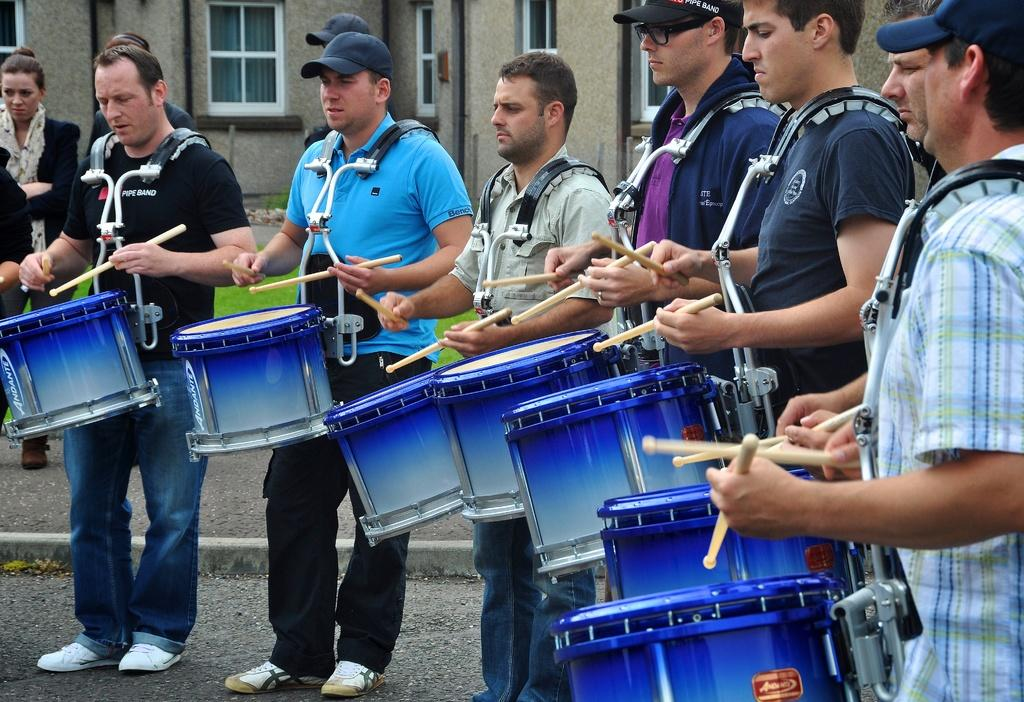What are the people in the image doing? The people in the image are playing drums. Where are the people located in the image? The people are standing in the center of the image. What can be seen in the background of the image? There is a building in the background of the image. What is at the bottom of the image? There is a road at the bottom of the image. Reasoning: Let' Let's think step by step in order to produce the conversation. We start by identifying the main action taking place in the image, which is the people playing drums. Then, we describe the location of the people within the image, followed by the background and the bottom of the image. Each question is designed to elicit a specific detail about the image that is known from the provided facts. Absurd Question/Answer: What type of quartz can be seen in the image? There is no quartz present in the image. Is there an amusement park in the image? The image does not show an amusement park; it features people playing drums and a building in the background. What type of quartz can be seen in the image? There is no quartz present in the image. Is there an amusement park in the image? The image does not show an amusement park; it features people playing drums and a building in the background. 